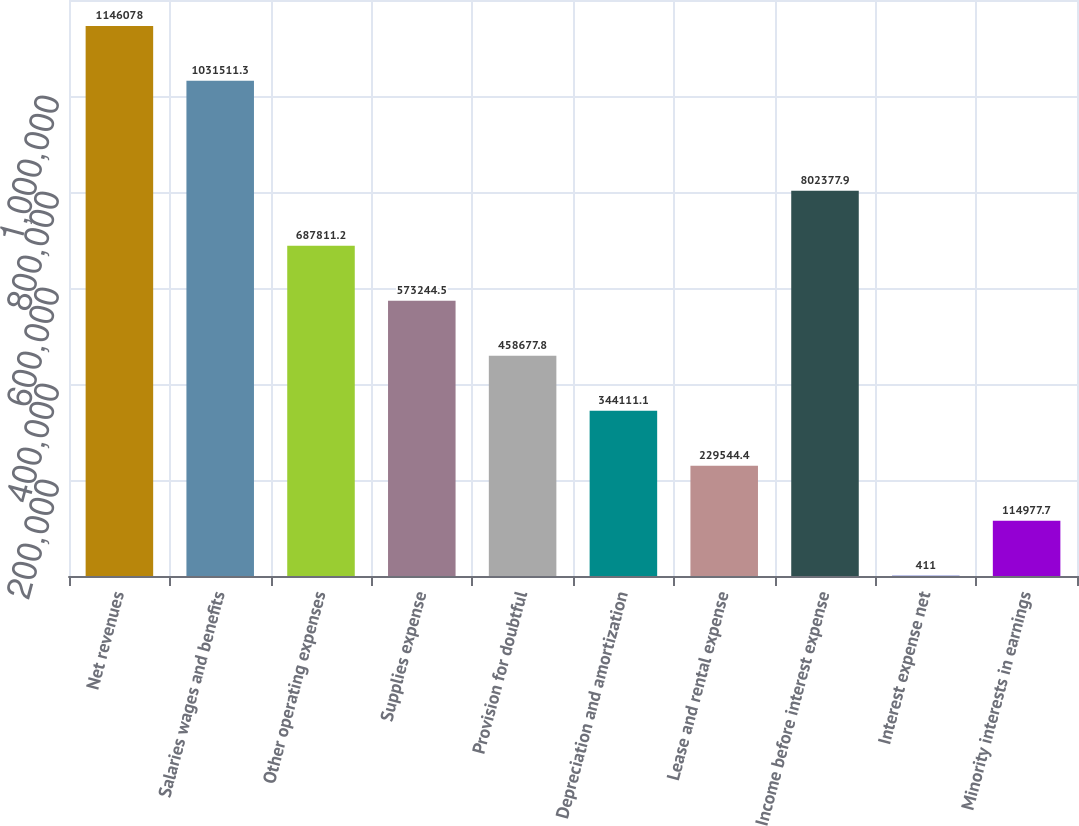Convert chart to OTSL. <chart><loc_0><loc_0><loc_500><loc_500><bar_chart><fcel>Net revenues<fcel>Salaries wages and benefits<fcel>Other operating expenses<fcel>Supplies expense<fcel>Provision for doubtful<fcel>Depreciation and amortization<fcel>Lease and rental expense<fcel>Income before interest expense<fcel>Interest expense net<fcel>Minority interests in earnings<nl><fcel>1.14608e+06<fcel>1.03151e+06<fcel>687811<fcel>573244<fcel>458678<fcel>344111<fcel>229544<fcel>802378<fcel>411<fcel>114978<nl></chart> 